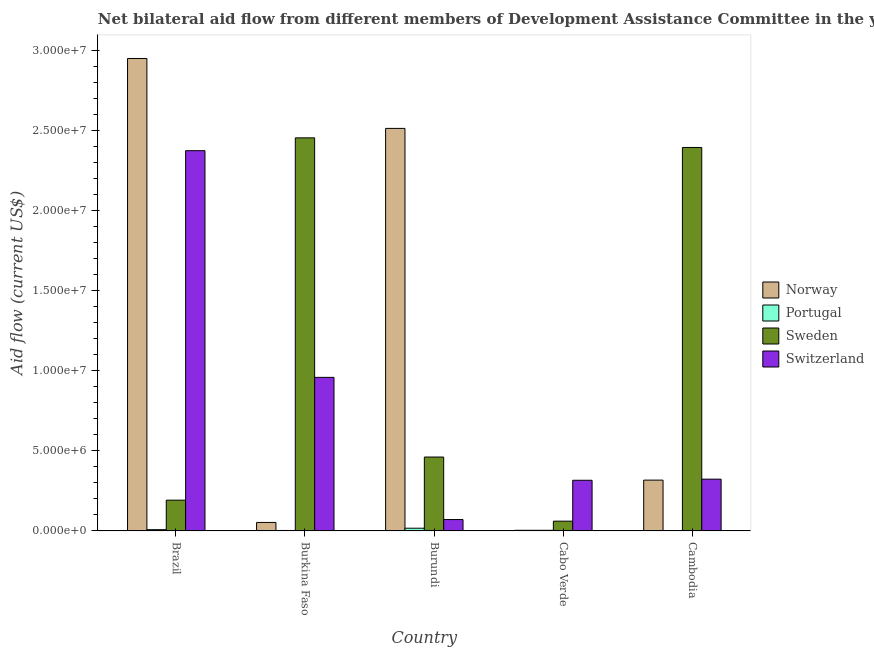How many different coloured bars are there?
Provide a short and direct response. 4. How many groups of bars are there?
Ensure brevity in your answer.  5. Are the number of bars per tick equal to the number of legend labels?
Give a very brief answer. Yes. How many bars are there on the 3rd tick from the left?
Your response must be concise. 4. How many bars are there on the 3rd tick from the right?
Give a very brief answer. 4. In how many cases, is the number of bars for a given country not equal to the number of legend labels?
Provide a succinct answer. 0. What is the amount of aid given by norway in Cabo Verde?
Offer a terse response. 4.00e+04. Across all countries, what is the maximum amount of aid given by norway?
Ensure brevity in your answer.  2.95e+07. Across all countries, what is the minimum amount of aid given by portugal?
Provide a short and direct response. 2.00e+04. In which country was the amount of aid given by portugal maximum?
Offer a very short reply. Burundi. In which country was the amount of aid given by switzerland minimum?
Provide a short and direct response. Burundi. What is the total amount of aid given by norway in the graph?
Your answer should be very brief. 5.83e+07. What is the difference between the amount of aid given by sweden in Burundi and that in Cabo Verde?
Keep it short and to the point. 4.00e+06. What is the difference between the amount of aid given by switzerland in Burkina Faso and the amount of aid given by norway in Burundi?
Provide a succinct answer. -1.55e+07. What is the average amount of aid given by norway per country?
Your response must be concise. 1.17e+07. What is the difference between the amount of aid given by sweden and amount of aid given by switzerland in Cabo Verde?
Make the answer very short. -2.55e+06. In how many countries, is the amount of aid given by portugal greater than 17000000 US$?
Ensure brevity in your answer.  0. What is the ratio of the amount of aid given by portugal in Brazil to that in Burkina Faso?
Provide a succinct answer. 2.67. Is the amount of aid given by norway in Brazil less than that in Burundi?
Your response must be concise. No. Is the difference between the amount of aid given by switzerland in Cabo Verde and Cambodia greater than the difference between the amount of aid given by sweden in Cabo Verde and Cambodia?
Your response must be concise. Yes. What is the difference between the highest and the second highest amount of aid given by portugal?
Offer a terse response. 9.00e+04. What is the difference between the highest and the lowest amount of aid given by portugal?
Your answer should be compact. 1.50e+05. In how many countries, is the amount of aid given by portugal greater than the average amount of aid given by portugal taken over all countries?
Offer a terse response. 2. Is the sum of the amount of aid given by portugal in Burkina Faso and Cabo Verde greater than the maximum amount of aid given by sweden across all countries?
Ensure brevity in your answer.  No. What does the 2nd bar from the left in Cabo Verde represents?
Your answer should be very brief. Portugal. What does the 4th bar from the right in Burkina Faso represents?
Offer a terse response. Norway. How many bars are there?
Provide a short and direct response. 20. Are all the bars in the graph horizontal?
Provide a short and direct response. No. What is the difference between two consecutive major ticks on the Y-axis?
Offer a very short reply. 5.00e+06. Are the values on the major ticks of Y-axis written in scientific E-notation?
Provide a succinct answer. Yes. Does the graph contain any zero values?
Provide a short and direct response. No. Does the graph contain grids?
Your response must be concise. No. How many legend labels are there?
Make the answer very short. 4. How are the legend labels stacked?
Offer a very short reply. Vertical. What is the title of the graph?
Provide a succinct answer. Net bilateral aid flow from different members of Development Assistance Committee in the year 2009. Does "Terrestrial protected areas" appear as one of the legend labels in the graph?
Make the answer very short. No. What is the Aid flow (current US$) of Norway in Brazil?
Make the answer very short. 2.95e+07. What is the Aid flow (current US$) in Sweden in Brazil?
Offer a very short reply. 1.92e+06. What is the Aid flow (current US$) of Switzerland in Brazil?
Provide a short and direct response. 2.37e+07. What is the Aid flow (current US$) in Norway in Burkina Faso?
Your response must be concise. 5.30e+05. What is the Aid flow (current US$) of Portugal in Burkina Faso?
Offer a very short reply. 3.00e+04. What is the Aid flow (current US$) in Sweden in Burkina Faso?
Your answer should be compact. 2.45e+07. What is the Aid flow (current US$) of Switzerland in Burkina Faso?
Offer a very short reply. 9.58e+06. What is the Aid flow (current US$) in Norway in Burundi?
Ensure brevity in your answer.  2.51e+07. What is the Aid flow (current US$) of Sweden in Burundi?
Offer a very short reply. 4.61e+06. What is the Aid flow (current US$) in Switzerland in Burundi?
Your response must be concise. 7.10e+05. What is the Aid flow (current US$) of Norway in Cabo Verde?
Your answer should be very brief. 4.00e+04. What is the Aid flow (current US$) of Portugal in Cabo Verde?
Your answer should be very brief. 4.00e+04. What is the Aid flow (current US$) in Switzerland in Cabo Verde?
Provide a short and direct response. 3.16e+06. What is the Aid flow (current US$) in Norway in Cambodia?
Provide a succinct answer. 3.17e+06. What is the Aid flow (current US$) in Sweden in Cambodia?
Your answer should be very brief. 2.39e+07. What is the Aid flow (current US$) in Switzerland in Cambodia?
Make the answer very short. 3.23e+06. Across all countries, what is the maximum Aid flow (current US$) of Norway?
Give a very brief answer. 2.95e+07. Across all countries, what is the maximum Aid flow (current US$) of Sweden?
Your answer should be compact. 2.45e+07. Across all countries, what is the maximum Aid flow (current US$) in Switzerland?
Ensure brevity in your answer.  2.37e+07. Across all countries, what is the minimum Aid flow (current US$) of Norway?
Ensure brevity in your answer.  4.00e+04. Across all countries, what is the minimum Aid flow (current US$) of Portugal?
Your response must be concise. 2.00e+04. Across all countries, what is the minimum Aid flow (current US$) in Switzerland?
Your answer should be very brief. 7.10e+05. What is the total Aid flow (current US$) in Norway in the graph?
Offer a very short reply. 5.83e+07. What is the total Aid flow (current US$) in Sweden in the graph?
Offer a terse response. 5.56e+07. What is the total Aid flow (current US$) of Switzerland in the graph?
Your answer should be compact. 4.04e+07. What is the difference between the Aid flow (current US$) of Norway in Brazil and that in Burkina Faso?
Keep it short and to the point. 2.89e+07. What is the difference between the Aid flow (current US$) in Portugal in Brazil and that in Burkina Faso?
Provide a short and direct response. 5.00e+04. What is the difference between the Aid flow (current US$) of Sweden in Brazil and that in Burkina Faso?
Keep it short and to the point. -2.26e+07. What is the difference between the Aid flow (current US$) in Switzerland in Brazil and that in Burkina Faso?
Keep it short and to the point. 1.41e+07. What is the difference between the Aid flow (current US$) in Norway in Brazil and that in Burundi?
Your response must be concise. 4.36e+06. What is the difference between the Aid flow (current US$) of Sweden in Brazil and that in Burundi?
Make the answer very short. -2.69e+06. What is the difference between the Aid flow (current US$) of Switzerland in Brazil and that in Burundi?
Give a very brief answer. 2.30e+07. What is the difference between the Aid flow (current US$) in Norway in Brazil and that in Cabo Verde?
Your response must be concise. 2.94e+07. What is the difference between the Aid flow (current US$) in Portugal in Brazil and that in Cabo Verde?
Your answer should be compact. 4.00e+04. What is the difference between the Aid flow (current US$) of Sweden in Brazil and that in Cabo Verde?
Offer a terse response. 1.31e+06. What is the difference between the Aid flow (current US$) of Switzerland in Brazil and that in Cabo Verde?
Give a very brief answer. 2.06e+07. What is the difference between the Aid flow (current US$) in Norway in Brazil and that in Cambodia?
Ensure brevity in your answer.  2.63e+07. What is the difference between the Aid flow (current US$) of Portugal in Brazil and that in Cambodia?
Give a very brief answer. 6.00e+04. What is the difference between the Aid flow (current US$) in Sweden in Brazil and that in Cambodia?
Offer a very short reply. -2.20e+07. What is the difference between the Aid flow (current US$) of Switzerland in Brazil and that in Cambodia?
Offer a very short reply. 2.05e+07. What is the difference between the Aid flow (current US$) in Norway in Burkina Faso and that in Burundi?
Ensure brevity in your answer.  -2.46e+07. What is the difference between the Aid flow (current US$) of Portugal in Burkina Faso and that in Burundi?
Your response must be concise. -1.40e+05. What is the difference between the Aid flow (current US$) of Sweden in Burkina Faso and that in Burundi?
Your answer should be very brief. 1.99e+07. What is the difference between the Aid flow (current US$) in Switzerland in Burkina Faso and that in Burundi?
Ensure brevity in your answer.  8.87e+06. What is the difference between the Aid flow (current US$) in Portugal in Burkina Faso and that in Cabo Verde?
Give a very brief answer. -10000. What is the difference between the Aid flow (current US$) in Sweden in Burkina Faso and that in Cabo Verde?
Make the answer very short. 2.39e+07. What is the difference between the Aid flow (current US$) of Switzerland in Burkina Faso and that in Cabo Verde?
Keep it short and to the point. 6.42e+06. What is the difference between the Aid flow (current US$) in Norway in Burkina Faso and that in Cambodia?
Your response must be concise. -2.64e+06. What is the difference between the Aid flow (current US$) of Portugal in Burkina Faso and that in Cambodia?
Offer a terse response. 10000. What is the difference between the Aid flow (current US$) in Sweden in Burkina Faso and that in Cambodia?
Offer a very short reply. 6.00e+05. What is the difference between the Aid flow (current US$) in Switzerland in Burkina Faso and that in Cambodia?
Provide a succinct answer. 6.35e+06. What is the difference between the Aid flow (current US$) in Norway in Burundi and that in Cabo Verde?
Keep it short and to the point. 2.51e+07. What is the difference between the Aid flow (current US$) in Portugal in Burundi and that in Cabo Verde?
Provide a short and direct response. 1.30e+05. What is the difference between the Aid flow (current US$) of Sweden in Burundi and that in Cabo Verde?
Ensure brevity in your answer.  4.00e+06. What is the difference between the Aid flow (current US$) in Switzerland in Burundi and that in Cabo Verde?
Your response must be concise. -2.45e+06. What is the difference between the Aid flow (current US$) in Norway in Burundi and that in Cambodia?
Your answer should be very brief. 2.19e+07. What is the difference between the Aid flow (current US$) in Portugal in Burundi and that in Cambodia?
Your answer should be very brief. 1.50e+05. What is the difference between the Aid flow (current US$) in Sweden in Burundi and that in Cambodia?
Provide a succinct answer. -1.93e+07. What is the difference between the Aid flow (current US$) in Switzerland in Burundi and that in Cambodia?
Offer a terse response. -2.52e+06. What is the difference between the Aid flow (current US$) of Norway in Cabo Verde and that in Cambodia?
Make the answer very short. -3.13e+06. What is the difference between the Aid flow (current US$) of Sweden in Cabo Verde and that in Cambodia?
Give a very brief answer. -2.33e+07. What is the difference between the Aid flow (current US$) in Switzerland in Cabo Verde and that in Cambodia?
Provide a short and direct response. -7.00e+04. What is the difference between the Aid flow (current US$) of Norway in Brazil and the Aid flow (current US$) of Portugal in Burkina Faso?
Make the answer very short. 2.94e+07. What is the difference between the Aid flow (current US$) in Norway in Brazil and the Aid flow (current US$) in Sweden in Burkina Faso?
Provide a succinct answer. 4.95e+06. What is the difference between the Aid flow (current US$) in Norway in Brazil and the Aid flow (current US$) in Switzerland in Burkina Faso?
Keep it short and to the point. 1.99e+07. What is the difference between the Aid flow (current US$) of Portugal in Brazil and the Aid flow (current US$) of Sweden in Burkina Faso?
Offer a very short reply. -2.44e+07. What is the difference between the Aid flow (current US$) in Portugal in Brazil and the Aid flow (current US$) in Switzerland in Burkina Faso?
Give a very brief answer. -9.50e+06. What is the difference between the Aid flow (current US$) of Sweden in Brazil and the Aid flow (current US$) of Switzerland in Burkina Faso?
Offer a very short reply. -7.66e+06. What is the difference between the Aid flow (current US$) in Norway in Brazil and the Aid flow (current US$) in Portugal in Burundi?
Provide a short and direct response. 2.93e+07. What is the difference between the Aid flow (current US$) in Norway in Brazil and the Aid flow (current US$) in Sweden in Burundi?
Make the answer very short. 2.49e+07. What is the difference between the Aid flow (current US$) in Norway in Brazil and the Aid flow (current US$) in Switzerland in Burundi?
Keep it short and to the point. 2.88e+07. What is the difference between the Aid flow (current US$) of Portugal in Brazil and the Aid flow (current US$) of Sweden in Burundi?
Your answer should be compact. -4.53e+06. What is the difference between the Aid flow (current US$) of Portugal in Brazil and the Aid flow (current US$) of Switzerland in Burundi?
Your response must be concise. -6.30e+05. What is the difference between the Aid flow (current US$) in Sweden in Brazil and the Aid flow (current US$) in Switzerland in Burundi?
Your answer should be very brief. 1.21e+06. What is the difference between the Aid flow (current US$) in Norway in Brazil and the Aid flow (current US$) in Portugal in Cabo Verde?
Offer a terse response. 2.94e+07. What is the difference between the Aid flow (current US$) of Norway in Brazil and the Aid flow (current US$) of Sweden in Cabo Verde?
Provide a succinct answer. 2.89e+07. What is the difference between the Aid flow (current US$) in Norway in Brazil and the Aid flow (current US$) in Switzerland in Cabo Verde?
Keep it short and to the point. 2.63e+07. What is the difference between the Aid flow (current US$) of Portugal in Brazil and the Aid flow (current US$) of Sweden in Cabo Verde?
Provide a short and direct response. -5.30e+05. What is the difference between the Aid flow (current US$) of Portugal in Brazil and the Aid flow (current US$) of Switzerland in Cabo Verde?
Your response must be concise. -3.08e+06. What is the difference between the Aid flow (current US$) of Sweden in Brazil and the Aid flow (current US$) of Switzerland in Cabo Verde?
Offer a very short reply. -1.24e+06. What is the difference between the Aid flow (current US$) of Norway in Brazil and the Aid flow (current US$) of Portugal in Cambodia?
Your answer should be very brief. 2.94e+07. What is the difference between the Aid flow (current US$) of Norway in Brazil and the Aid flow (current US$) of Sweden in Cambodia?
Offer a terse response. 5.55e+06. What is the difference between the Aid flow (current US$) of Norway in Brazil and the Aid flow (current US$) of Switzerland in Cambodia?
Offer a terse response. 2.62e+07. What is the difference between the Aid flow (current US$) in Portugal in Brazil and the Aid flow (current US$) in Sweden in Cambodia?
Offer a terse response. -2.38e+07. What is the difference between the Aid flow (current US$) of Portugal in Brazil and the Aid flow (current US$) of Switzerland in Cambodia?
Your answer should be very brief. -3.15e+06. What is the difference between the Aid flow (current US$) of Sweden in Brazil and the Aid flow (current US$) of Switzerland in Cambodia?
Your answer should be compact. -1.31e+06. What is the difference between the Aid flow (current US$) in Norway in Burkina Faso and the Aid flow (current US$) in Sweden in Burundi?
Offer a very short reply. -4.08e+06. What is the difference between the Aid flow (current US$) of Norway in Burkina Faso and the Aid flow (current US$) of Switzerland in Burundi?
Ensure brevity in your answer.  -1.80e+05. What is the difference between the Aid flow (current US$) of Portugal in Burkina Faso and the Aid flow (current US$) of Sweden in Burundi?
Your response must be concise. -4.58e+06. What is the difference between the Aid flow (current US$) of Portugal in Burkina Faso and the Aid flow (current US$) of Switzerland in Burundi?
Keep it short and to the point. -6.80e+05. What is the difference between the Aid flow (current US$) of Sweden in Burkina Faso and the Aid flow (current US$) of Switzerland in Burundi?
Offer a very short reply. 2.38e+07. What is the difference between the Aid flow (current US$) in Norway in Burkina Faso and the Aid flow (current US$) in Switzerland in Cabo Verde?
Offer a very short reply. -2.63e+06. What is the difference between the Aid flow (current US$) of Portugal in Burkina Faso and the Aid flow (current US$) of Sweden in Cabo Verde?
Your answer should be very brief. -5.80e+05. What is the difference between the Aid flow (current US$) of Portugal in Burkina Faso and the Aid flow (current US$) of Switzerland in Cabo Verde?
Give a very brief answer. -3.13e+06. What is the difference between the Aid flow (current US$) of Sweden in Burkina Faso and the Aid flow (current US$) of Switzerland in Cabo Verde?
Keep it short and to the point. 2.14e+07. What is the difference between the Aid flow (current US$) of Norway in Burkina Faso and the Aid flow (current US$) of Portugal in Cambodia?
Provide a short and direct response. 5.10e+05. What is the difference between the Aid flow (current US$) in Norway in Burkina Faso and the Aid flow (current US$) in Sweden in Cambodia?
Your response must be concise. -2.34e+07. What is the difference between the Aid flow (current US$) of Norway in Burkina Faso and the Aid flow (current US$) of Switzerland in Cambodia?
Provide a succinct answer. -2.70e+06. What is the difference between the Aid flow (current US$) of Portugal in Burkina Faso and the Aid flow (current US$) of Sweden in Cambodia?
Make the answer very short. -2.39e+07. What is the difference between the Aid flow (current US$) of Portugal in Burkina Faso and the Aid flow (current US$) of Switzerland in Cambodia?
Offer a terse response. -3.20e+06. What is the difference between the Aid flow (current US$) of Sweden in Burkina Faso and the Aid flow (current US$) of Switzerland in Cambodia?
Make the answer very short. 2.13e+07. What is the difference between the Aid flow (current US$) in Norway in Burundi and the Aid flow (current US$) in Portugal in Cabo Verde?
Your response must be concise. 2.51e+07. What is the difference between the Aid flow (current US$) in Norway in Burundi and the Aid flow (current US$) in Sweden in Cabo Verde?
Offer a terse response. 2.45e+07. What is the difference between the Aid flow (current US$) of Norway in Burundi and the Aid flow (current US$) of Switzerland in Cabo Verde?
Provide a succinct answer. 2.20e+07. What is the difference between the Aid flow (current US$) of Portugal in Burundi and the Aid flow (current US$) of Sweden in Cabo Verde?
Keep it short and to the point. -4.40e+05. What is the difference between the Aid flow (current US$) of Portugal in Burundi and the Aid flow (current US$) of Switzerland in Cabo Verde?
Keep it short and to the point. -2.99e+06. What is the difference between the Aid flow (current US$) of Sweden in Burundi and the Aid flow (current US$) of Switzerland in Cabo Verde?
Make the answer very short. 1.45e+06. What is the difference between the Aid flow (current US$) in Norway in Burundi and the Aid flow (current US$) in Portugal in Cambodia?
Offer a terse response. 2.51e+07. What is the difference between the Aid flow (current US$) of Norway in Burundi and the Aid flow (current US$) of Sweden in Cambodia?
Give a very brief answer. 1.19e+06. What is the difference between the Aid flow (current US$) of Norway in Burundi and the Aid flow (current US$) of Switzerland in Cambodia?
Provide a short and direct response. 2.19e+07. What is the difference between the Aid flow (current US$) of Portugal in Burundi and the Aid flow (current US$) of Sweden in Cambodia?
Keep it short and to the point. -2.38e+07. What is the difference between the Aid flow (current US$) in Portugal in Burundi and the Aid flow (current US$) in Switzerland in Cambodia?
Provide a short and direct response. -3.06e+06. What is the difference between the Aid flow (current US$) in Sweden in Burundi and the Aid flow (current US$) in Switzerland in Cambodia?
Give a very brief answer. 1.38e+06. What is the difference between the Aid flow (current US$) in Norway in Cabo Verde and the Aid flow (current US$) in Portugal in Cambodia?
Make the answer very short. 2.00e+04. What is the difference between the Aid flow (current US$) of Norway in Cabo Verde and the Aid flow (current US$) of Sweden in Cambodia?
Your answer should be compact. -2.39e+07. What is the difference between the Aid flow (current US$) in Norway in Cabo Verde and the Aid flow (current US$) in Switzerland in Cambodia?
Your response must be concise. -3.19e+06. What is the difference between the Aid flow (current US$) of Portugal in Cabo Verde and the Aid flow (current US$) of Sweden in Cambodia?
Your response must be concise. -2.39e+07. What is the difference between the Aid flow (current US$) in Portugal in Cabo Verde and the Aid flow (current US$) in Switzerland in Cambodia?
Give a very brief answer. -3.19e+06. What is the difference between the Aid flow (current US$) of Sweden in Cabo Verde and the Aid flow (current US$) of Switzerland in Cambodia?
Offer a terse response. -2.62e+06. What is the average Aid flow (current US$) in Norway per country?
Ensure brevity in your answer.  1.17e+07. What is the average Aid flow (current US$) of Portugal per country?
Ensure brevity in your answer.  6.80e+04. What is the average Aid flow (current US$) in Sweden per country?
Provide a succinct answer. 1.11e+07. What is the average Aid flow (current US$) in Switzerland per country?
Offer a terse response. 8.08e+06. What is the difference between the Aid flow (current US$) of Norway and Aid flow (current US$) of Portugal in Brazil?
Ensure brevity in your answer.  2.94e+07. What is the difference between the Aid flow (current US$) of Norway and Aid flow (current US$) of Sweden in Brazil?
Your answer should be very brief. 2.76e+07. What is the difference between the Aid flow (current US$) of Norway and Aid flow (current US$) of Switzerland in Brazil?
Your response must be concise. 5.75e+06. What is the difference between the Aid flow (current US$) of Portugal and Aid flow (current US$) of Sweden in Brazil?
Provide a succinct answer. -1.84e+06. What is the difference between the Aid flow (current US$) of Portugal and Aid flow (current US$) of Switzerland in Brazil?
Offer a terse response. -2.36e+07. What is the difference between the Aid flow (current US$) of Sweden and Aid flow (current US$) of Switzerland in Brazil?
Ensure brevity in your answer.  -2.18e+07. What is the difference between the Aid flow (current US$) in Norway and Aid flow (current US$) in Portugal in Burkina Faso?
Your response must be concise. 5.00e+05. What is the difference between the Aid flow (current US$) in Norway and Aid flow (current US$) in Sweden in Burkina Faso?
Give a very brief answer. -2.40e+07. What is the difference between the Aid flow (current US$) in Norway and Aid flow (current US$) in Switzerland in Burkina Faso?
Offer a terse response. -9.05e+06. What is the difference between the Aid flow (current US$) of Portugal and Aid flow (current US$) of Sweden in Burkina Faso?
Your answer should be compact. -2.45e+07. What is the difference between the Aid flow (current US$) in Portugal and Aid flow (current US$) in Switzerland in Burkina Faso?
Keep it short and to the point. -9.55e+06. What is the difference between the Aid flow (current US$) of Sweden and Aid flow (current US$) of Switzerland in Burkina Faso?
Offer a terse response. 1.49e+07. What is the difference between the Aid flow (current US$) of Norway and Aid flow (current US$) of Portugal in Burundi?
Offer a very short reply. 2.49e+07. What is the difference between the Aid flow (current US$) of Norway and Aid flow (current US$) of Sweden in Burundi?
Your answer should be compact. 2.05e+07. What is the difference between the Aid flow (current US$) of Norway and Aid flow (current US$) of Switzerland in Burundi?
Ensure brevity in your answer.  2.44e+07. What is the difference between the Aid flow (current US$) of Portugal and Aid flow (current US$) of Sweden in Burundi?
Your answer should be very brief. -4.44e+06. What is the difference between the Aid flow (current US$) in Portugal and Aid flow (current US$) in Switzerland in Burundi?
Provide a short and direct response. -5.40e+05. What is the difference between the Aid flow (current US$) in Sweden and Aid flow (current US$) in Switzerland in Burundi?
Offer a very short reply. 3.90e+06. What is the difference between the Aid flow (current US$) of Norway and Aid flow (current US$) of Sweden in Cabo Verde?
Offer a very short reply. -5.70e+05. What is the difference between the Aid flow (current US$) in Norway and Aid flow (current US$) in Switzerland in Cabo Verde?
Provide a short and direct response. -3.12e+06. What is the difference between the Aid flow (current US$) in Portugal and Aid flow (current US$) in Sweden in Cabo Verde?
Provide a short and direct response. -5.70e+05. What is the difference between the Aid flow (current US$) of Portugal and Aid flow (current US$) of Switzerland in Cabo Verde?
Give a very brief answer. -3.12e+06. What is the difference between the Aid flow (current US$) in Sweden and Aid flow (current US$) in Switzerland in Cabo Verde?
Your answer should be very brief. -2.55e+06. What is the difference between the Aid flow (current US$) of Norway and Aid flow (current US$) of Portugal in Cambodia?
Provide a short and direct response. 3.15e+06. What is the difference between the Aid flow (current US$) in Norway and Aid flow (current US$) in Sweden in Cambodia?
Provide a short and direct response. -2.08e+07. What is the difference between the Aid flow (current US$) in Norway and Aid flow (current US$) in Switzerland in Cambodia?
Ensure brevity in your answer.  -6.00e+04. What is the difference between the Aid flow (current US$) in Portugal and Aid flow (current US$) in Sweden in Cambodia?
Give a very brief answer. -2.39e+07. What is the difference between the Aid flow (current US$) in Portugal and Aid flow (current US$) in Switzerland in Cambodia?
Your answer should be very brief. -3.21e+06. What is the difference between the Aid flow (current US$) of Sweden and Aid flow (current US$) of Switzerland in Cambodia?
Offer a terse response. 2.07e+07. What is the ratio of the Aid flow (current US$) of Norway in Brazil to that in Burkina Faso?
Offer a terse response. 55.6. What is the ratio of the Aid flow (current US$) of Portugal in Brazil to that in Burkina Faso?
Give a very brief answer. 2.67. What is the ratio of the Aid flow (current US$) in Sweden in Brazil to that in Burkina Faso?
Your answer should be compact. 0.08. What is the ratio of the Aid flow (current US$) in Switzerland in Brazil to that in Burkina Faso?
Provide a succinct answer. 2.48. What is the ratio of the Aid flow (current US$) of Norway in Brazil to that in Burundi?
Provide a short and direct response. 1.17. What is the ratio of the Aid flow (current US$) of Portugal in Brazil to that in Burundi?
Provide a short and direct response. 0.47. What is the ratio of the Aid flow (current US$) in Sweden in Brazil to that in Burundi?
Ensure brevity in your answer.  0.42. What is the ratio of the Aid flow (current US$) of Switzerland in Brazil to that in Burundi?
Offer a terse response. 33.41. What is the ratio of the Aid flow (current US$) of Norway in Brazil to that in Cabo Verde?
Your answer should be compact. 736.75. What is the ratio of the Aid flow (current US$) in Sweden in Brazil to that in Cabo Verde?
Offer a very short reply. 3.15. What is the ratio of the Aid flow (current US$) in Switzerland in Brazil to that in Cabo Verde?
Your answer should be compact. 7.51. What is the ratio of the Aid flow (current US$) in Norway in Brazil to that in Cambodia?
Your response must be concise. 9.3. What is the ratio of the Aid flow (current US$) of Portugal in Brazil to that in Cambodia?
Your answer should be compact. 4. What is the ratio of the Aid flow (current US$) in Sweden in Brazil to that in Cambodia?
Provide a succinct answer. 0.08. What is the ratio of the Aid flow (current US$) in Switzerland in Brazil to that in Cambodia?
Make the answer very short. 7.34. What is the ratio of the Aid flow (current US$) of Norway in Burkina Faso to that in Burundi?
Your response must be concise. 0.02. What is the ratio of the Aid flow (current US$) of Portugal in Burkina Faso to that in Burundi?
Provide a short and direct response. 0.18. What is the ratio of the Aid flow (current US$) of Sweden in Burkina Faso to that in Burundi?
Keep it short and to the point. 5.32. What is the ratio of the Aid flow (current US$) of Switzerland in Burkina Faso to that in Burundi?
Give a very brief answer. 13.49. What is the ratio of the Aid flow (current US$) of Norway in Burkina Faso to that in Cabo Verde?
Your response must be concise. 13.25. What is the ratio of the Aid flow (current US$) of Sweden in Burkina Faso to that in Cabo Verde?
Your answer should be very brief. 40.2. What is the ratio of the Aid flow (current US$) of Switzerland in Burkina Faso to that in Cabo Verde?
Offer a very short reply. 3.03. What is the ratio of the Aid flow (current US$) in Norway in Burkina Faso to that in Cambodia?
Make the answer very short. 0.17. What is the ratio of the Aid flow (current US$) in Sweden in Burkina Faso to that in Cambodia?
Provide a succinct answer. 1.03. What is the ratio of the Aid flow (current US$) in Switzerland in Burkina Faso to that in Cambodia?
Provide a short and direct response. 2.97. What is the ratio of the Aid flow (current US$) of Norway in Burundi to that in Cabo Verde?
Keep it short and to the point. 627.75. What is the ratio of the Aid flow (current US$) of Portugal in Burundi to that in Cabo Verde?
Your response must be concise. 4.25. What is the ratio of the Aid flow (current US$) of Sweden in Burundi to that in Cabo Verde?
Ensure brevity in your answer.  7.56. What is the ratio of the Aid flow (current US$) in Switzerland in Burundi to that in Cabo Verde?
Offer a very short reply. 0.22. What is the ratio of the Aid flow (current US$) of Norway in Burundi to that in Cambodia?
Offer a very short reply. 7.92. What is the ratio of the Aid flow (current US$) in Portugal in Burundi to that in Cambodia?
Ensure brevity in your answer.  8.5. What is the ratio of the Aid flow (current US$) in Sweden in Burundi to that in Cambodia?
Make the answer very short. 0.19. What is the ratio of the Aid flow (current US$) in Switzerland in Burundi to that in Cambodia?
Make the answer very short. 0.22. What is the ratio of the Aid flow (current US$) of Norway in Cabo Verde to that in Cambodia?
Provide a succinct answer. 0.01. What is the ratio of the Aid flow (current US$) of Sweden in Cabo Verde to that in Cambodia?
Provide a succinct answer. 0.03. What is the ratio of the Aid flow (current US$) in Switzerland in Cabo Verde to that in Cambodia?
Provide a short and direct response. 0.98. What is the difference between the highest and the second highest Aid flow (current US$) in Norway?
Provide a succinct answer. 4.36e+06. What is the difference between the highest and the second highest Aid flow (current US$) in Portugal?
Offer a very short reply. 9.00e+04. What is the difference between the highest and the second highest Aid flow (current US$) in Switzerland?
Make the answer very short. 1.41e+07. What is the difference between the highest and the lowest Aid flow (current US$) in Norway?
Your answer should be very brief. 2.94e+07. What is the difference between the highest and the lowest Aid flow (current US$) of Portugal?
Make the answer very short. 1.50e+05. What is the difference between the highest and the lowest Aid flow (current US$) of Sweden?
Your answer should be compact. 2.39e+07. What is the difference between the highest and the lowest Aid flow (current US$) in Switzerland?
Offer a very short reply. 2.30e+07. 